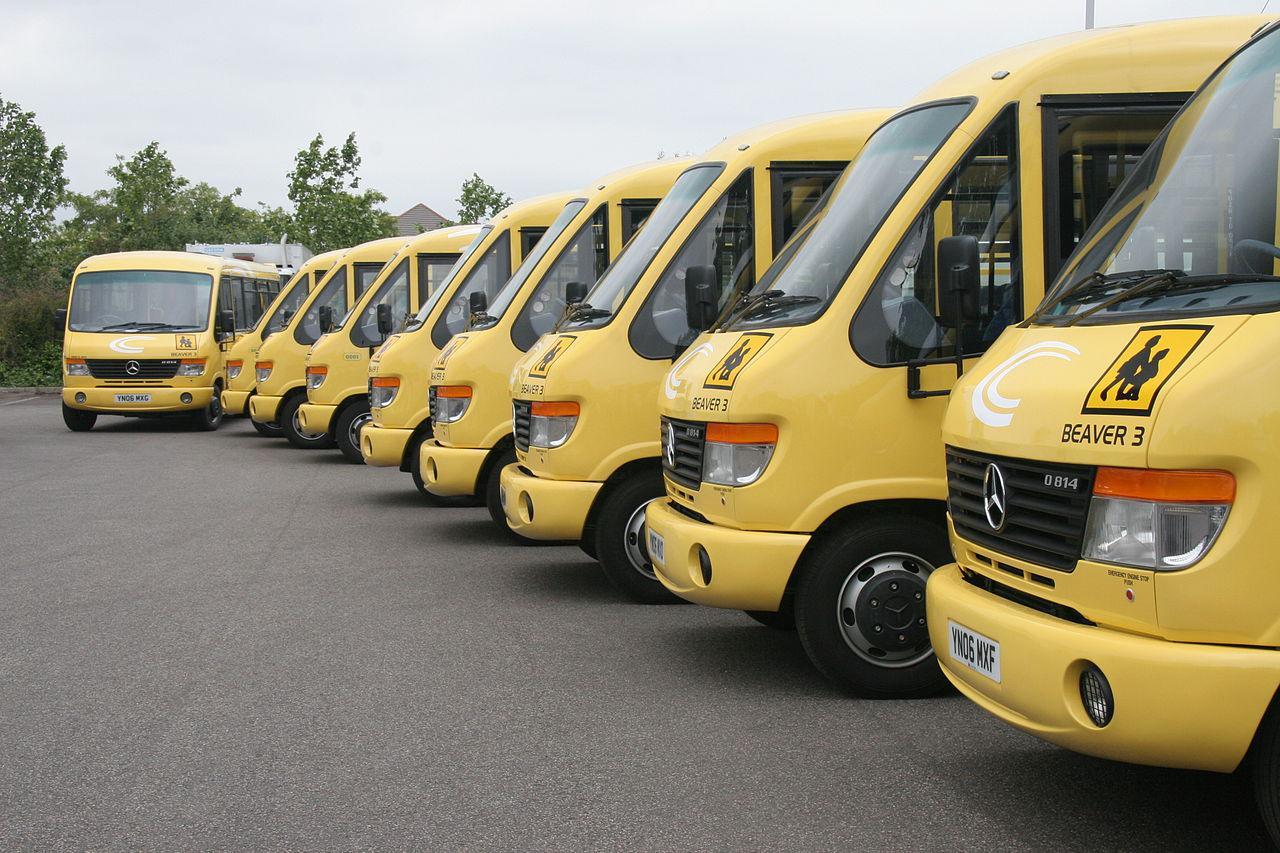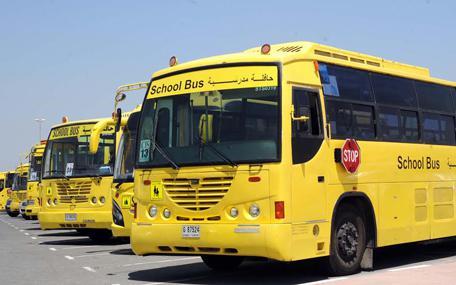The first image is the image on the left, the second image is the image on the right. Given the left and right images, does the statement "One of the pictures shows at least six school buses parked next to each other." hold true? Answer yes or no. Yes. The first image is the image on the left, the second image is the image on the right. Analyze the images presented: Is the assertion "All images show flat-fronted buses parked at a forward angle, and at least one image features a bus with yellow downturned shapes on either side of the windshield." valid? Answer yes or no. No. 